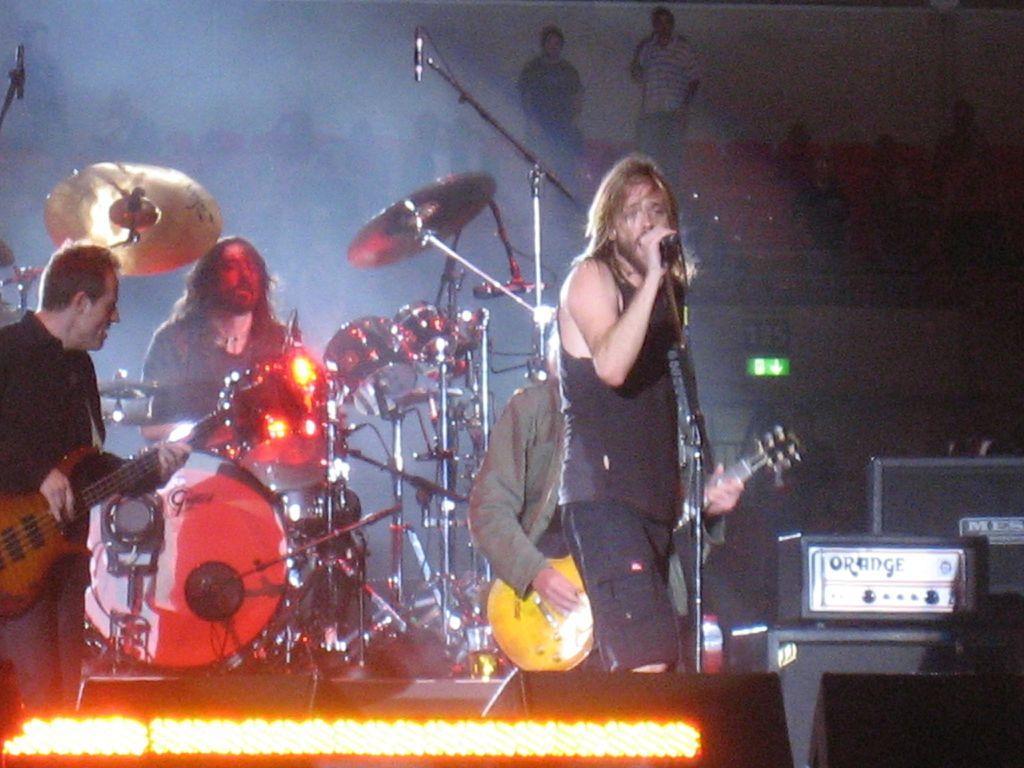In one or two sentences, can you explain what this image depicts? In this image I can see a man standing and singing by holding mike in his hands. On the left side of the image I can see a man wearing black color shirt, standing and playing the guitar. Beside this person there is another person is playing the drums. In the background I can see few people are sitting on the chairs and there are two persons are standing. 